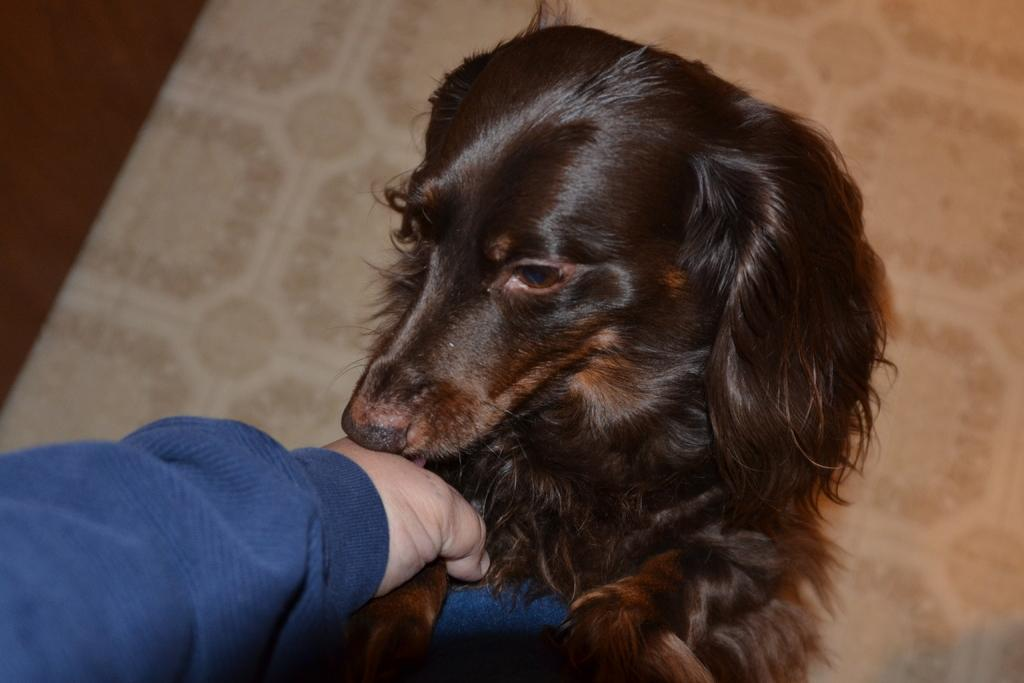What part of a person can be seen in the image? There is a hand of a person in the image. What type of animal is present in the image? There is a dog in the image. What surface is visible in the image? The floor is visible in the image. What number is written on the credit card in the image? There is no credit card present in the image. 